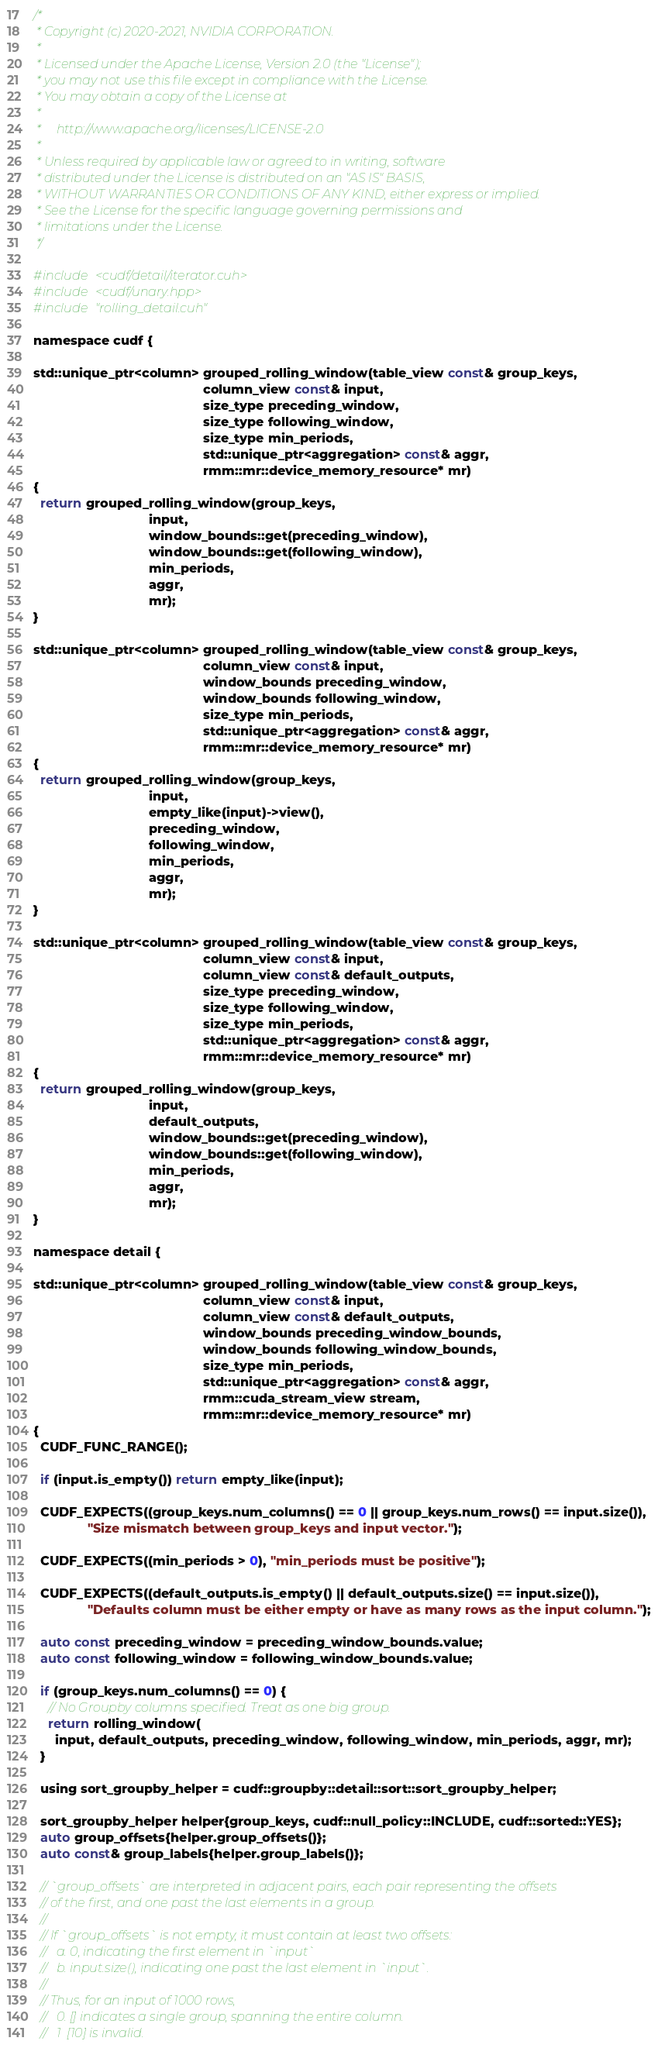Convert code to text. <code><loc_0><loc_0><loc_500><loc_500><_Cuda_>/*
 * Copyright (c) 2020-2021, NVIDIA CORPORATION.
 *
 * Licensed under the Apache License, Version 2.0 (the "License");
 * you may not use this file except in compliance with the License.
 * You may obtain a copy of the License at
 *
 *     http://www.apache.org/licenses/LICENSE-2.0
 *
 * Unless required by applicable law or agreed to in writing, software
 * distributed under the License is distributed on an "AS IS" BASIS,
 * WITHOUT WARRANTIES OR CONDITIONS OF ANY KIND, either express or implied.
 * See the License for the specific language governing permissions and
 * limitations under the License.
 */

#include <cudf/detail/iterator.cuh>
#include <cudf/unary.hpp>
#include "rolling_detail.cuh"

namespace cudf {

std::unique_ptr<column> grouped_rolling_window(table_view const& group_keys,
                                               column_view const& input,
                                               size_type preceding_window,
                                               size_type following_window,
                                               size_type min_periods,
                                               std::unique_ptr<aggregation> const& aggr,
                                               rmm::mr::device_memory_resource* mr)
{
  return grouped_rolling_window(group_keys,
                                input,
                                window_bounds::get(preceding_window),
                                window_bounds::get(following_window),
                                min_periods,
                                aggr,
                                mr);
}

std::unique_ptr<column> grouped_rolling_window(table_view const& group_keys,
                                               column_view const& input,
                                               window_bounds preceding_window,
                                               window_bounds following_window,
                                               size_type min_periods,
                                               std::unique_ptr<aggregation> const& aggr,
                                               rmm::mr::device_memory_resource* mr)
{
  return grouped_rolling_window(group_keys,
                                input,
                                empty_like(input)->view(),
                                preceding_window,
                                following_window,
                                min_periods,
                                aggr,
                                mr);
}

std::unique_ptr<column> grouped_rolling_window(table_view const& group_keys,
                                               column_view const& input,
                                               column_view const& default_outputs,
                                               size_type preceding_window,
                                               size_type following_window,
                                               size_type min_periods,
                                               std::unique_ptr<aggregation> const& aggr,
                                               rmm::mr::device_memory_resource* mr)
{
  return grouped_rolling_window(group_keys,
                                input,
                                default_outputs,
                                window_bounds::get(preceding_window),
                                window_bounds::get(following_window),
                                min_periods,
                                aggr,
                                mr);
}

namespace detail {

std::unique_ptr<column> grouped_rolling_window(table_view const& group_keys,
                                               column_view const& input,
                                               column_view const& default_outputs,
                                               window_bounds preceding_window_bounds,
                                               window_bounds following_window_bounds,
                                               size_type min_periods,
                                               std::unique_ptr<aggregation> const& aggr,
                                               rmm::cuda_stream_view stream,
                                               rmm::mr::device_memory_resource* mr)
{
  CUDF_FUNC_RANGE();

  if (input.is_empty()) return empty_like(input);

  CUDF_EXPECTS((group_keys.num_columns() == 0 || group_keys.num_rows() == input.size()),
               "Size mismatch between group_keys and input vector.");

  CUDF_EXPECTS((min_periods > 0), "min_periods must be positive");

  CUDF_EXPECTS((default_outputs.is_empty() || default_outputs.size() == input.size()),
               "Defaults column must be either empty or have as many rows as the input column.");

  auto const preceding_window = preceding_window_bounds.value;
  auto const following_window = following_window_bounds.value;

  if (group_keys.num_columns() == 0) {
    // No Groupby columns specified. Treat as one big group.
    return rolling_window(
      input, default_outputs, preceding_window, following_window, min_periods, aggr, mr);
  }

  using sort_groupby_helper = cudf::groupby::detail::sort::sort_groupby_helper;

  sort_groupby_helper helper{group_keys, cudf::null_policy::INCLUDE, cudf::sorted::YES};
  auto group_offsets{helper.group_offsets()};
  auto const& group_labels{helper.group_labels()};

  // `group_offsets` are interpreted in adjacent pairs, each pair representing the offsets
  // of the first, and one past the last elements in a group.
  //
  // If `group_offsets` is not empty, it must contain at least two offsets:
  //   a. 0, indicating the first element in `input`
  //   b. input.size(), indicating one past the last element in `input`.
  //
  // Thus, for an input of 1000 rows,
  //   0. [] indicates a single group, spanning the entire column.
  //   1  [10] is invalid.</code> 